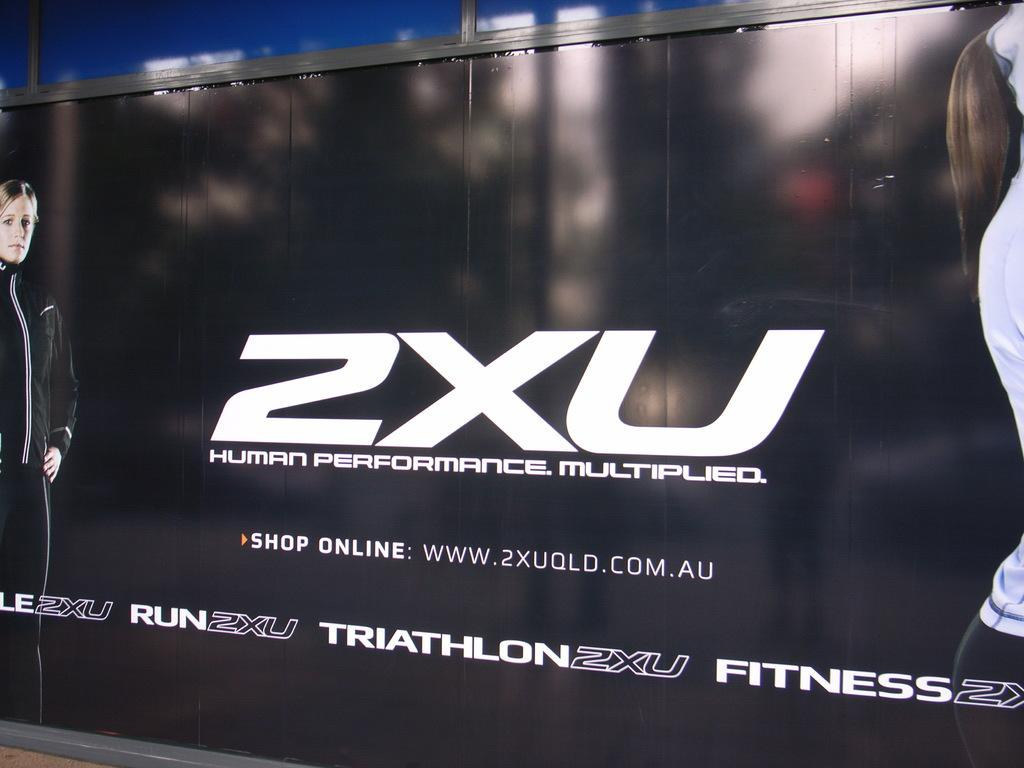<image>
Render a clear and concise summary of the photo. a large black advertiesement from human performance multiplied. 